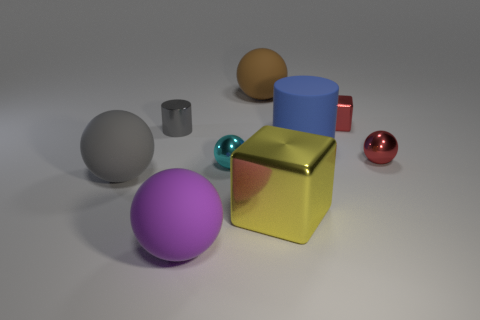Is there any pattern to the arrangement of the objects? The objects are arranged without a discernible pattern, spread out sporadically across the surface with varying distances between them, suggesting a random or unplanned layout. Might the arrangement imply any specific relations between the objects? The arrangement doesn't imply a clear relationship, but one might interpret the similar shapes and colors as grouped entities or discern a visual balance between the objects' positions and sizes. 